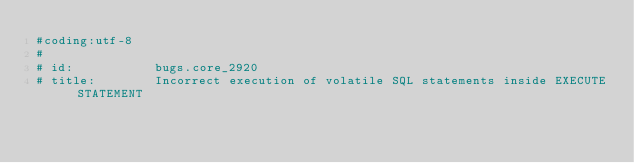<code> <loc_0><loc_0><loc_500><loc_500><_Python_>#coding:utf-8
#
# id:           bugs.core_2920
# title:        Incorrect execution of volatile SQL statements inside EXECUTE STATEMENT</code> 